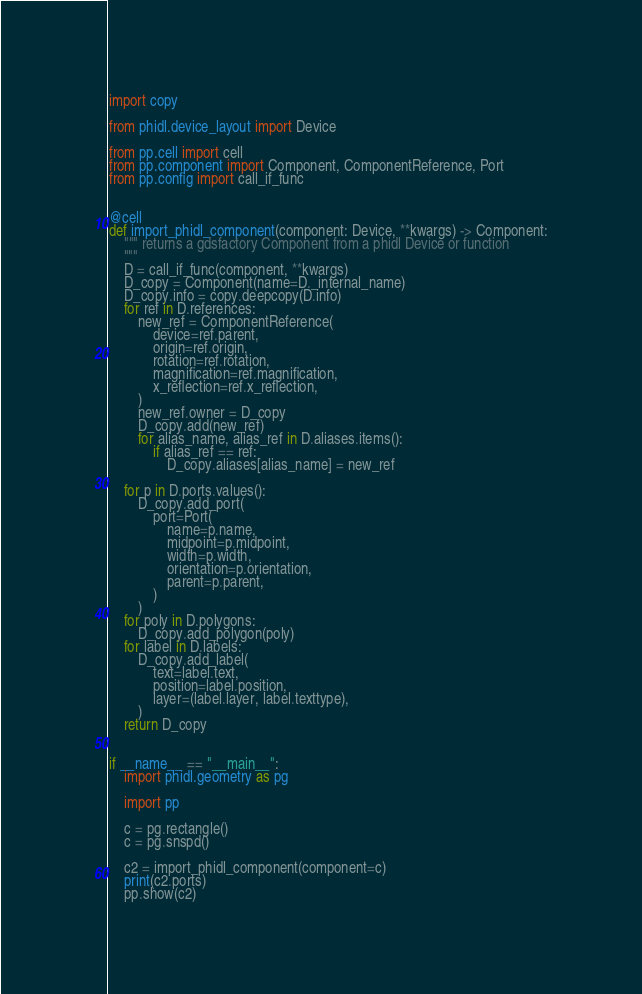Convert code to text. <code><loc_0><loc_0><loc_500><loc_500><_Python_>import copy

from phidl.device_layout import Device

from pp.cell import cell
from pp.component import Component, ComponentReference, Port
from pp.config import call_if_func


@cell
def import_phidl_component(component: Device, **kwargs) -> Component:
    """ returns a gdsfactory Component from a phidl Device or function
    """
    D = call_if_func(component, **kwargs)
    D_copy = Component(name=D._internal_name)
    D_copy.info = copy.deepcopy(D.info)
    for ref in D.references:
        new_ref = ComponentReference(
            device=ref.parent,
            origin=ref.origin,
            rotation=ref.rotation,
            magnification=ref.magnification,
            x_reflection=ref.x_reflection,
        )
        new_ref.owner = D_copy
        D_copy.add(new_ref)
        for alias_name, alias_ref in D.aliases.items():
            if alias_ref == ref:
                D_copy.aliases[alias_name] = new_ref

    for p in D.ports.values():
        D_copy.add_port(
            port=Port(
                name=p.name,
                midpoint=p.midpoint,
                width=p.width,
                orientation=p.orientation,
                parent=p.parent,
            )
        )
    for poly in D.polygons:
        D_copy.add_polygon(poly)
    for label in D.labels:
        D_copy.add_label(
            text=label.text,
            position=label.position,
            layer=(label.layer, label.texttype),
        )
    return D_copy


if __name__ == "__main__":
    import phidl.geometry as pg

    import pp

    c = pg.rectangle()
    c = pg.snspd()

    c2 = import_phidl_component(component=c)
    print(c2.ports)
    pp.show(c2)
</code> 